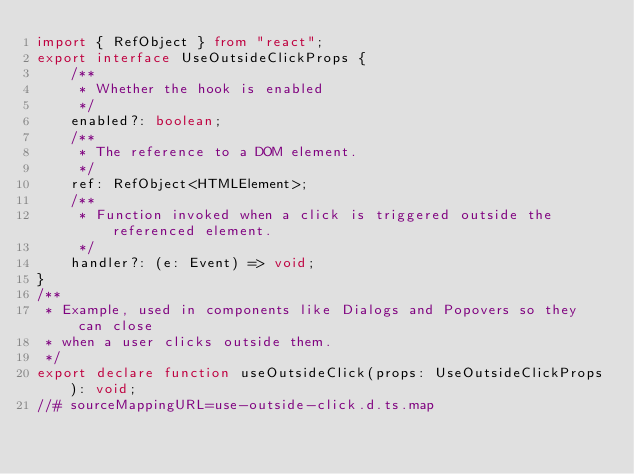Convert code to text. <code><loc_0><loc_0><loc_500><loc_500><_TypeScript_>import { RefObject } from "react";
export interface UseOutsideClickProps {
    /**
     * Whether the hook is enabled
     */
    enabled?: boolean;
    /**
     * The reference to a DOM element.
     */
    ref: RefObject<HTMLElement>;
    /**
     * Function invoked when a click is triggered outside the referenced element.
     */
    handler?: (e: Event) => void;
}
/**
 * Example, used in components like Dialogs and Popovers so they can close
 * when a user clicks outside them.
 */
export declare function useOutsideClick(props: UseOutsideClickProps): void;
//# sourceMappingURL=use-outside-click.d.ts.map</code> 